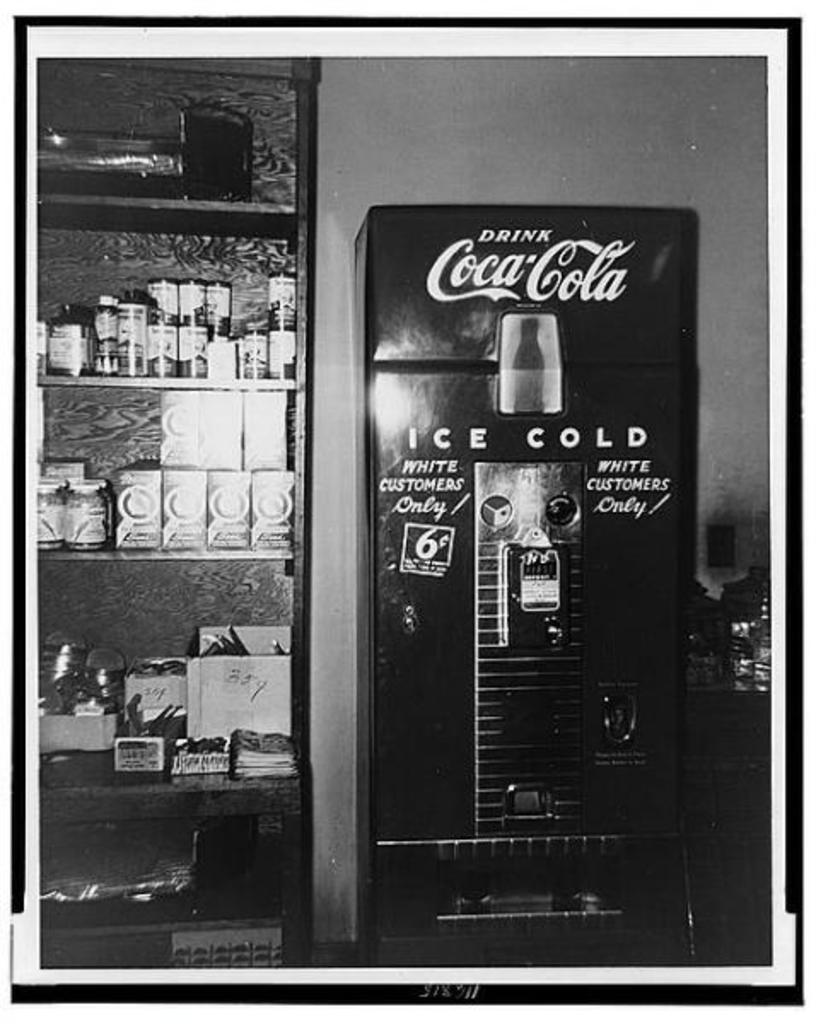<image>
Write a terse but informative summary of the picture. A vintage Coca-Cola machine that states it's for white customers only. 